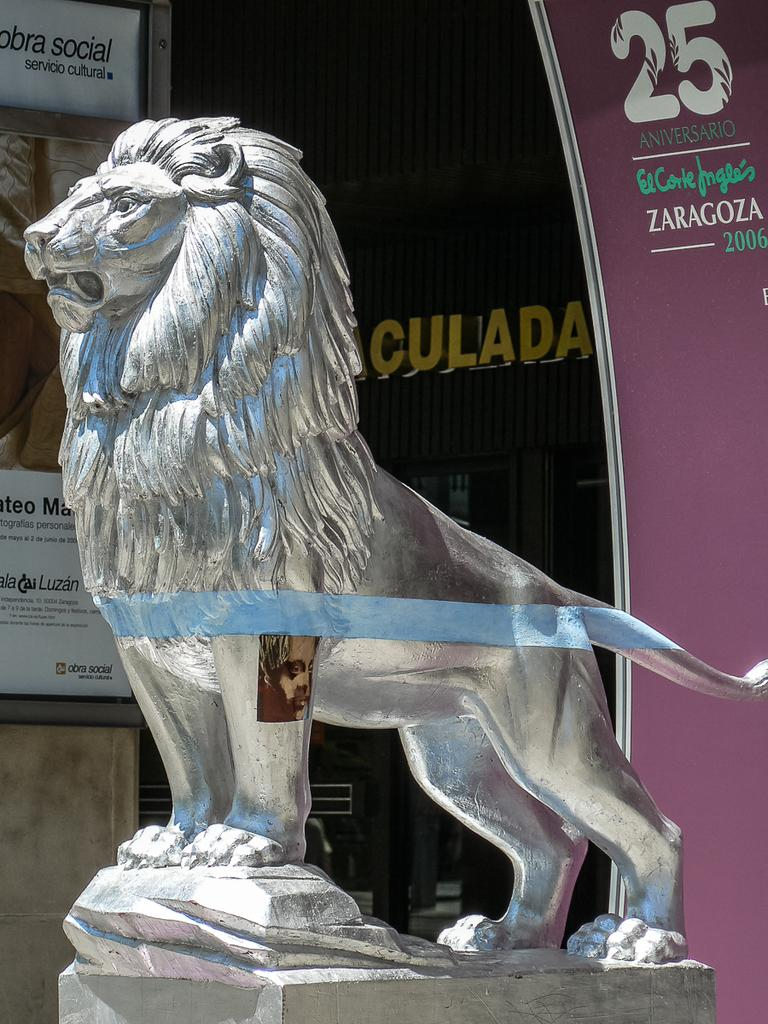What is the main subject in the image? There is a statue in the image. What else can be seen in the image besides the statue? There are boards with text and images in the image. What is visible in the background of the image? There is a wall with text in the background of the image. What type of mine is depicted in the image? There is no mine present in the image; it features a statue, boards with text and images, and a wall with text in the background. What color of paint is used on the statue in the image? The provided facts do not mention the color of paint on the statue, so we cannot determine that information from the image. 